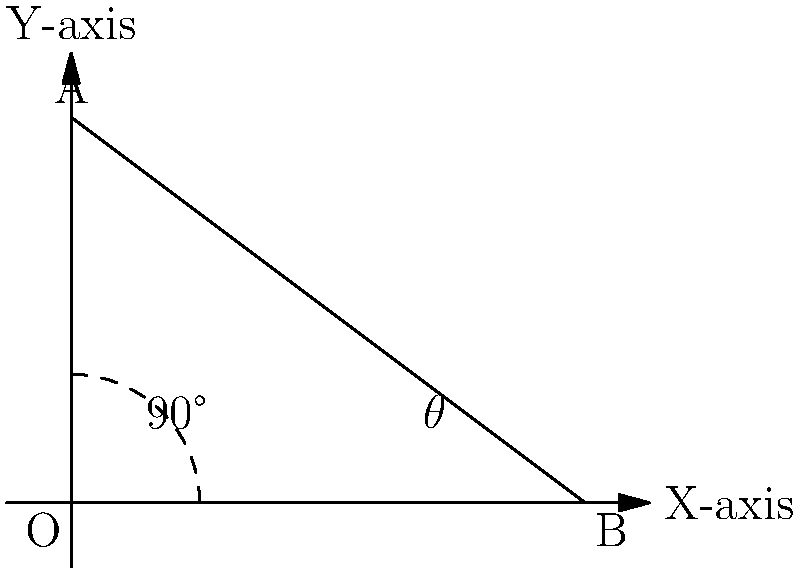In a recording studio setup, you're positioning a microphone to capture the perfect sound from your jazz ensemble. The microphone needs to be placed at an angle $\theta$ from the horizontal axis, as shown in the diagram. If the microphone's position is represented by point B with coordinates (4, 0), and its optimal direction is towards point A with coordinates (0, 3), what is the value of angle $\theta$ in degrees? To find the angle $\theta$, we can follow these steps:

1) First, we need to recognize that we have a right-angled triangle OAB, where O is the origin (0, 0).

2) We can use the arctangent function to find the angle. The arctangent of the ratio of the opposite side to the adjacent side will give us the angle in radians.

3) The opposite side is the y-coordinate of point A, which is 3.
   The adjacent side is the x-coordinate of point B, which is 4.

4) So, we can calculate $\theta$ as follows:
   $$\theta = \arctan(\frac{opposite}{adjacent}) = \arctan(\frac{3}{4})$$

5) This gives us the angle in radians. To convert to degrees, we multiply by $\frac{180}{\pi}$:
   $$\theta_{degrees} = \arctan(\frac{3}{4}) \cdot \frac{180}{\pi}$$

6) Calculating this:
   $$\theta_{degrees} \approx 36.87°$$

7) Rounding to the nearest degree:
   $$\theta \approx 37°$$

Therefore, the optimal angle for positioning the microphone is approximately 37 degrees from the horizontal axis.
Answer: 37° 